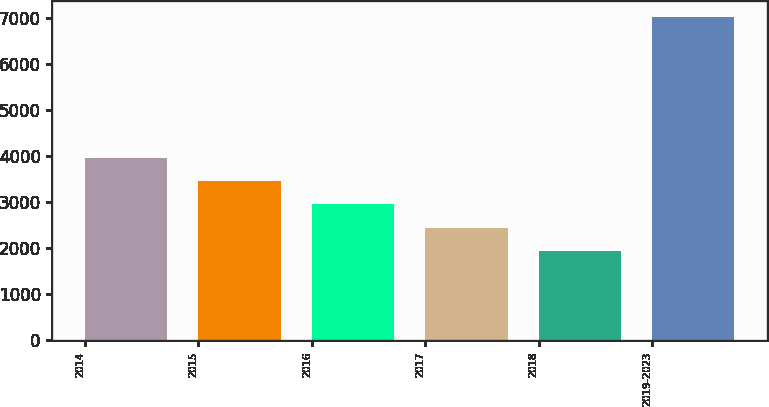Convert chart to OTSL. <chart><loc_0><loc_0><loc_500><loc_500><bar_chart><fcel>2014<fcel>2015<fcel>2016<fcel>2017<fcel>2018<fcel>2019-2023<nl><fcel>3967.8<fcel>3458.1<fcel>2948.4<fcel>2438.7<fcel>1929<fcel>7026<nl></chart> 